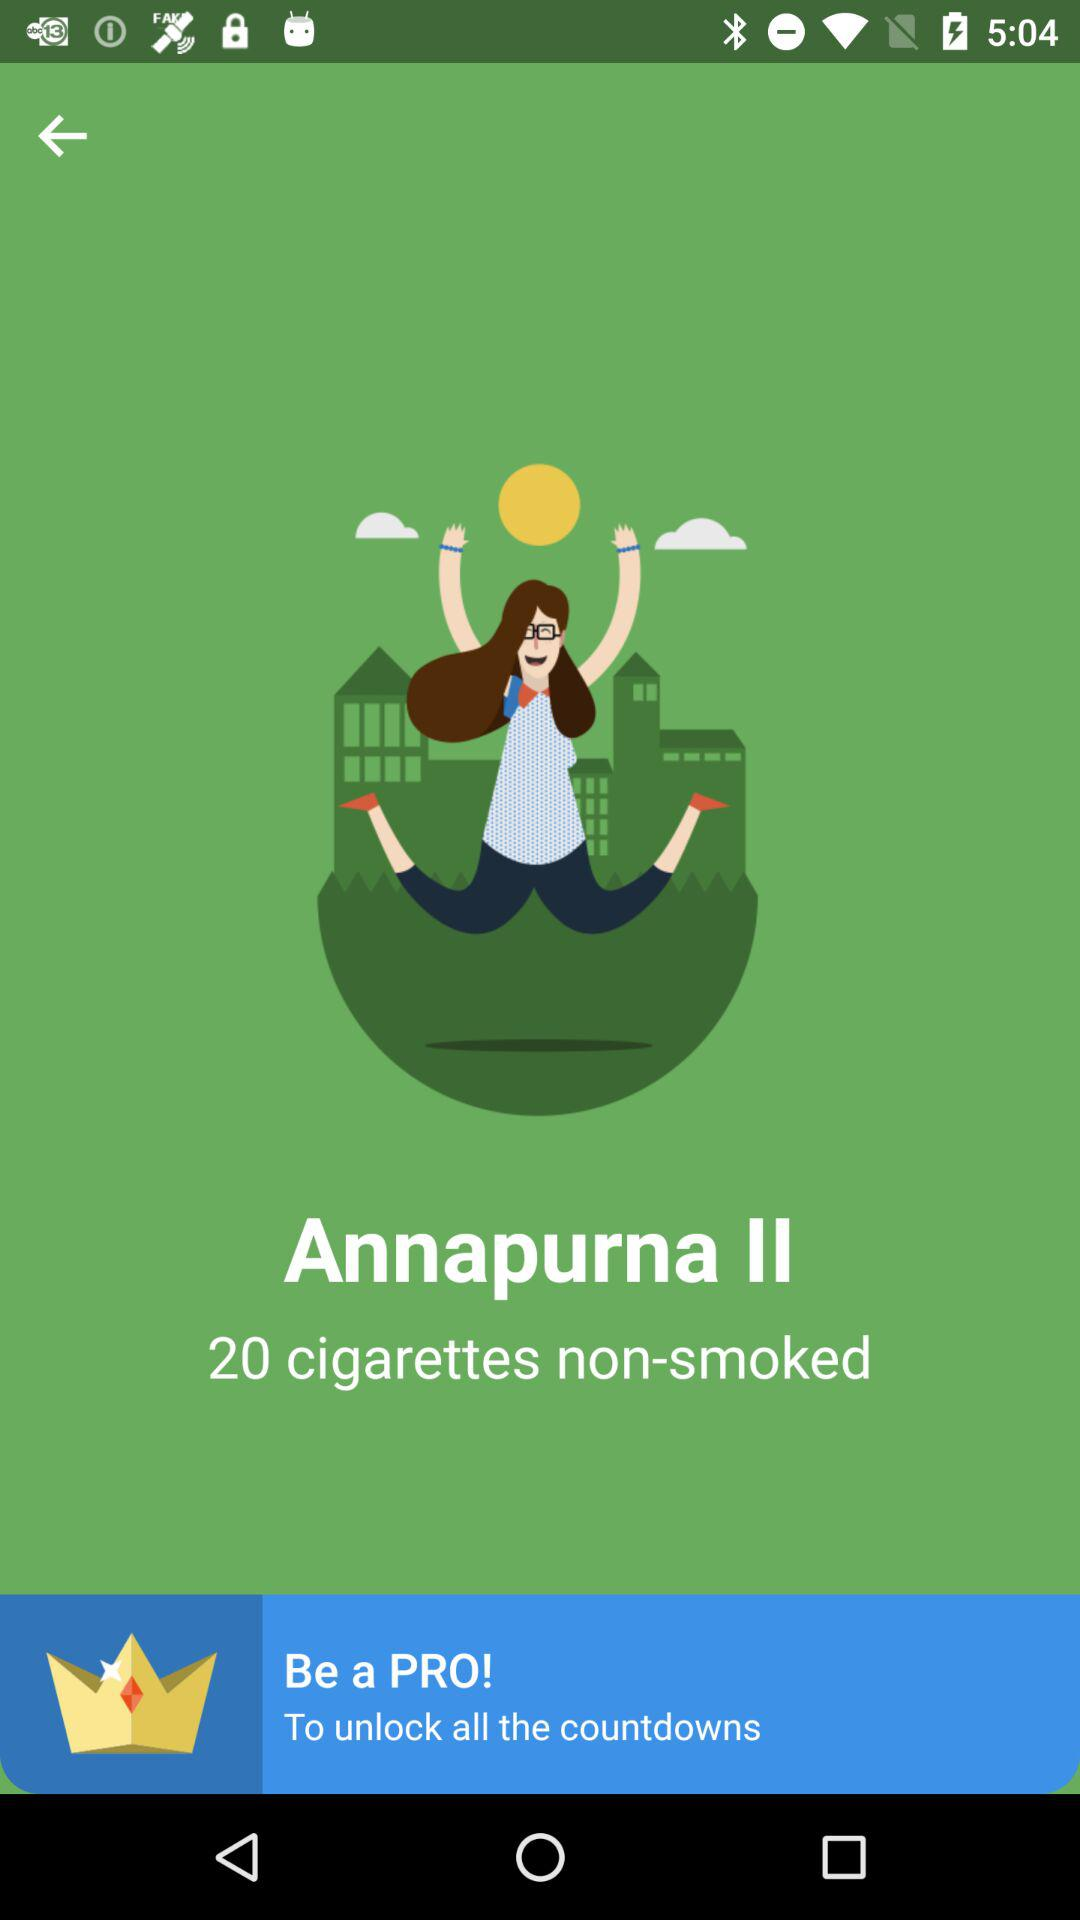How many cigarettes have I not smoked?
Answer the question using a single word or phrase. 20 